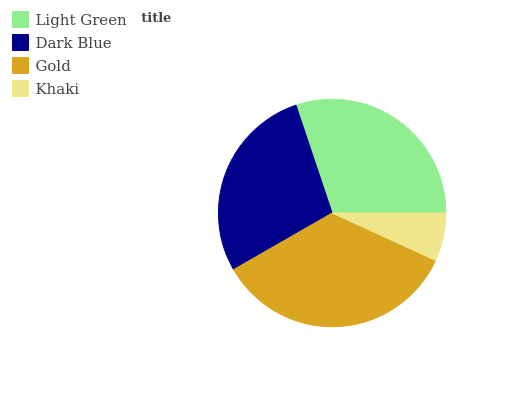Is Khaki the minimum?
Answer yes or no. Yes. Is Gold the maximum?
Answer yes or no. Yes. Is Dark Blue the minimum?
Answer yes or no. No. Is Dark Blue the maximum?
Answer yes or no. No. Is Light Green greater than Dark Blue?
Answer yes or no. Yes. Is Dark Blue less than Light Green?
Answer yes or no. Yes. Is Dark Blue greater than Light Green?
Answer yes or no. No. Is Light Green less than Dark Blue?
Answer yes or no. No. Is Light Green the high median?
Answer yes or no. Yes. Is Dark Blue the low median?
Answer yes or no. Yes. Is Gold the high median?
Answer yes or no. No. Is Light Green the low median?
Answer yes or no. No. 